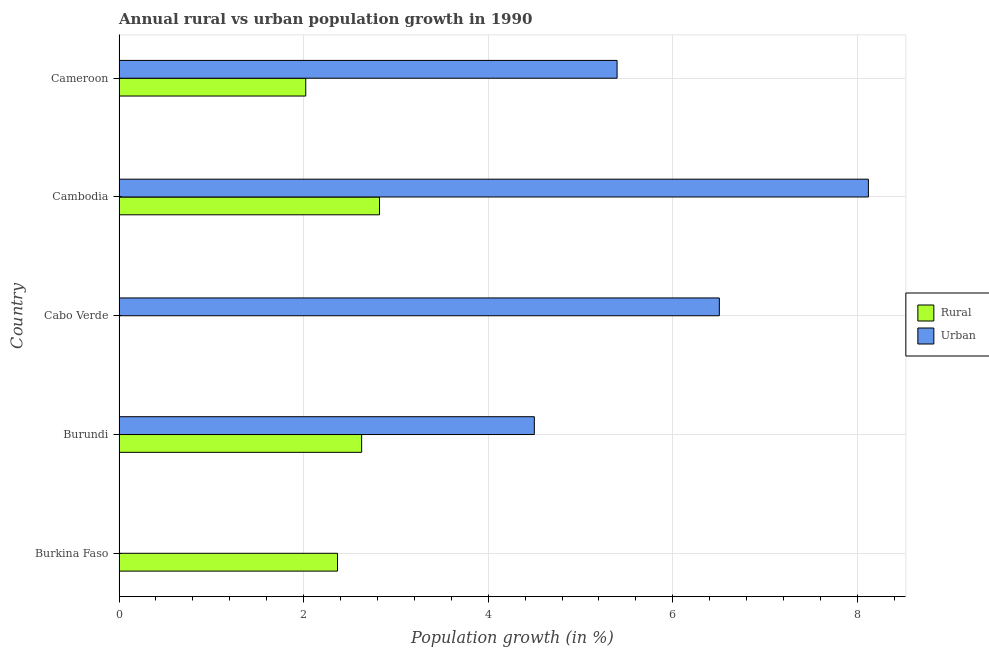How many different coloured bars are there?
Offer a terse response. 2. Are the number of bars on each tick of the Y-axis equal?
Make the answer very short. No. How many bars are there on the 2nd tick from the top?
Keep it short and to the point. 2. What is the label of the 3rd group of bars from the top?
Make the answer very short. Cabo Verde. In how many cases, is the number of bars for a given country not equal to the number of legend labels?
Keep it short and to the point. 2. What is the urban population growth in Cambodia?
Offer a terse response. 8.12. Across all countries, what is the maximum urban population growth?
Offer a very short reply. 8.12. In which country was the rural population growth maximum?
Your answer should be very brief. Cambodia. What is the total rural population growth in the graph?
Your answer should be very brief. 9.84. What is the difference between the rural population growth in Burkina Faso and that in Cambodia?
Make the answer very short. -0.46. What is the difference between the rural population growth in Burundi and the urban population growth in Burkina Faso?
Your response must be concise. 2.63. What is the average urban population growth per country?
Ensure brevity in your answer.  4.9. What is the difference between the urban population growth and rural population growth in Burundi?
Provide a short and direct response. 1.87. What is the ratio of the rural population growth in Burkina Faso to that in Burundi?
Ensure brevity in your answer.  0.9. Is the rural population growth in Burkina Faso less than that in Burundi?
Provide a short and direct response. Yes. What is the difference between the highest and the second highest rural population growth?
Provide a short and direct response. 0.19. What is the difference between the highest and the lowest urban population growth?
Offer a very short reply. 8.12. Is the sum of the urban population growth in Cabo Verde and Cameroon greater than the maximum rural population growth across all countries?
Provide a succinct answer. Yes. How many bars are there?
Offer a very short reply. 8. What is the difference between two consecutive major ticks on the X-axis?
Offer a terse response. 2. Are the values on the major ticks of X-axis written in scientific E-notation?
Make the answer very short. No. Does the graph contain any zero values?
Your response must be concise. Yes. Where does the legend appear in the graph?
Provide a succinct answer. Center right. How many legend labels are there?
Offer a terse response. 2. What is the title of the graph?
Keep it short and to the point. Annual rural vs urban population growth in 1990. Does "Attending school" appear as one of the legend labels in the graph?
Ensure brevity in your answer.  No. What is the label or title of the X-axis?
Provide a short and direct response. Population growth (in %). What is the Population growth (in %) of Rural in Burkina Faso?
Keep it short and to the point. 2.37. What is the Population growth (in %) of Rural in Burundi?
Your answer should be very brief. 2.63. What is the Population growth (in %) of Urban  in Burundi?
Make the answer very short. 4.5. What is the Population growth (in %) in Rural in Cabo Verde?
Make the answer very short. 0. What is the Population growth (in %) in Urban  in Cabo Verde?
Your answer should be compact. 6.5. What is the Population growth (in %) of Rural in Cambodia?
Ensure brevity in your answer.  2.82. What is the Population growth (in %) in Urban  in Cambodia?
Give a very brief answer. 8.12. What is the Population growth (in %) in Rural in Cameroon?
Ensure brevity in your answer.  2.02. What is the Population growth (in %) of Urban  in Cameroon?
Provide a succinct answer. 5.4. Across all countries, what is the maximum Population growth (in %) in Rural?
Offer a very short reply. 2.82. Across all countries, what is the maximum Population growth (in %) of Urban ?
Provide a short and direct response. 8.12. What is the total Population growth (in %) in Rural in the graph?
Your response must be concise. 9.84. What is the total Population growth (in %) of Urban  in the graph?
Your response must be concise. 24.52. What is the difference between the Population growth (in %) in Rural in Burkina Faso and that in Burundi?
Your answer should be compact. -0.26. What is the difference between the Population growth (in %) of Rural in Burkina Faso and that in Cambodia?
Your answer should be compact. -0.46. What is the difference between the Population growth (in %) in Rural in Burkina Faso and that in Cameroon?
Provide a short and direct response. 0.34. What is the difference between the Population growth (in %) of Urban  in Burundi and that in Cabo Verde?
Your answer should be very brief. -2. What is the difference between the Population growth (in %) in Rural in Burundi and that in Cambodia?
Your answer should be very brief. -0.19. What is the difference between the Population growth (in %) of Urban  in Burundi and that in Cambodia?
Your response must be concise. -3.62. What is the difference between the Population growth (in %) of Rural in Burundi and that in Cameroon?
Provide a succinct answer. 0.61. What is the difference between the Population growth (in %) of Urban  in Burundi and that in Cameroon?
Offer a terse response. -0.9. What is the difference between the Population growth (in %) in Urban  in Cabo Verde and that in Cambodia?
Your answer should be very brief. -1.61. What is the difference between the Population growth (in %) of Urban  in Cabo Verde and that in Cameroon?
Offer a very short reply. 1.11. What is the difference between the Population growth (in %) in Rural in Cambodia and that in Cameroon?
Provide a succinct answer. 0.8. What is the difference between the Population growth (in %) in Urban  in Cambodia and that in Cameroon?
Your response must be concise. 2.72. What is the difference between the Population growth (in %) in Rural in Burkina Faso and the Population growth (in %) in Urban  in Burundi?
Your answer should be very brief. -2.13. What is the difference between the Population growth (in %) of Rural in Burkina Faso and the Population growth (in %) of Urban  in Cabo Verde?
Your answer should be very brief. -4.14. What is the difference between the Population growth (in %) in Rural in Burkina Faso and the Population growth (in %) in Urban  in Cambodia?
Provide a succinct answer. -5.75. What is the difference between the Population growth (in %) of Rural in Burkina Faso and the Population growth (in %) of Urban  in Cameroon?
Keep it short and to the point. -3.03. What is the difference between the Population growth (in %) of Rural in Burundi and the Population growth (in %) of Urban  in Cabo Verde?
Ensure brevity in your answer.  -3.88. What is the difference between the Population growth (in %) of Rural in Burundi and the Population growth (in %) of Urban  in Cambodia?
Your response must be concise. -5.49. What is the difference between the Population growth (in %) in Rural in Burundi and the Population growth (in %) in Urban  in Cameroon?
Keep it short and to the point. -2.77. What is the difference between the Population growth (in %) of Rural in Cambodia and the Population growth (in %) of Urban  in Cameroon?
Provide a short and direct response. -2.57. What is the average Population growth (in %) in Rural per country?
Offer a very short reply. 1.97. What is the average Population growth (in %) in Urban  per country?
Provide a short and direct response. 4.9. What is the difference between the Population growth (in %) of Rural and Population growth (in %) of Urban  in Burundi?
Your response must be concise. -1.87. What is the difference between the Population growth (in %) of Rural and Population growth (in %) of Urban  in Cambodia?
Offer a very short reply. -5.3. What is the difference between the Population growth (in %) in Rural and Population growth (in %) in Urban  in Cameroon?
Your answer should be very brief. -3.37. What is the ratio of the Population growth (in %) of Rural in Burkina Faso to that in Burundi?
Your answer should be compact. 0.9. What is the ratio of the Population growth (in %) in Rural in Burkina Faso to that in Cambodia?
Offer a terse response. 0.84. What is the ratio of the Population growth (in %) in Rural in Burkina Faso to that in Cameroon?
Ensure brevity in your answer.  1.17. What is the ratio of the Population growth (in %) in Urban  in Burundi to that in Cabo Verde?
Offer a terse response. 0.69. What is the ratio of the Population growth (in %) of Rural in Burundi to that in Cambodia?
Offer a terse response. 0.93. What is the ratio of the Population growth (in %) of Urban  in Burundi to that in Cambodia?
Provide a short and direct response. 0.55. What is the ratio of the Population growth (in %) in Rural in Burundi to that in Cameroon?
Provide a succinct answer. 1.3. What is the ratio of the Population growth (in %) in Urban  in Burundi to that in Cameroon?
Give a very brief answer. 0.83. What is the ratio of the Population growth (in %) of Urban  in Cabo Verde to that in Cambodia?
Keep it short and to the point. 0.8. What is the ratio of the Population growth (in %) of Urban  in Cabo Verde to that in Cameroon?
Your answer should be very brief. 1.21. What is the ratio of the Population growth (in %) of Rural in Cambodia to that in Cameroon?
Provide a succinct answer. 1.4. What is the ratio of the Population growth (in %) in Urban  in Cambodia to that in Cameroon?
Your answer should be compact. 1.5. What is the difference between the highest and the second highest Population growth (in %) in Rural?
Offer a very short reply. 0.19. What is the difference between the highest and the second highest Population growth (in %) of Urban ?
Give a very brief answer. 1.61. What is the difference between the highest and the lowest Population growth (in %) in Rural?
Ensure brevity in your answer.  2.82. What is the difference between the highest and the lowest Population growth (in %) of Urban ?
Provide a succinct answer. 8.12. 